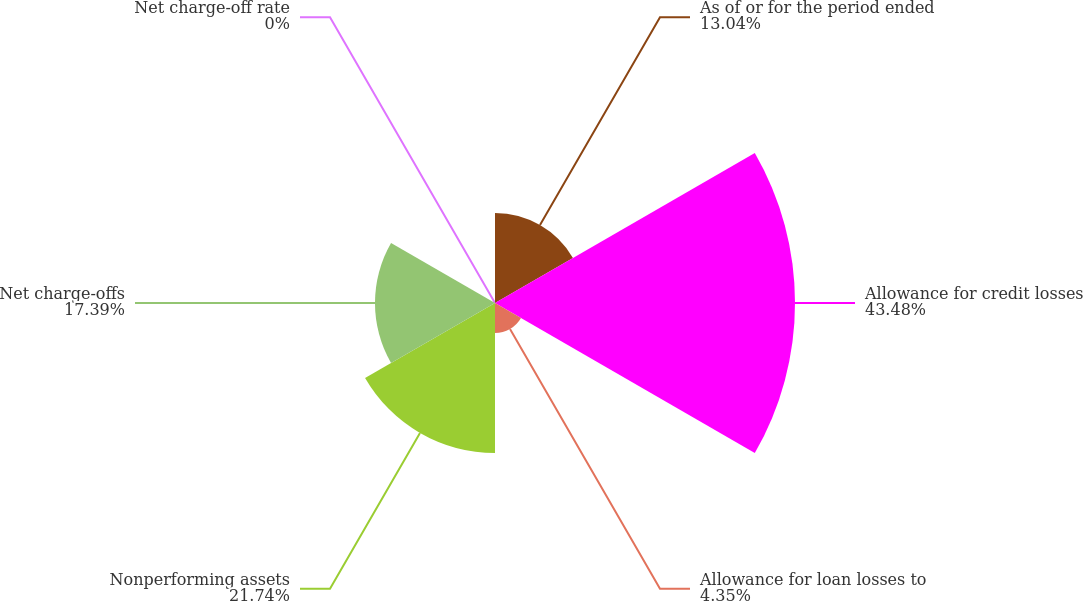<chart> <loc_0><loc_0><loc_500><loc_500><pie_chart><fcel>As of or for the period ended<fcel>Allowance for credit losses<fcel>Allowance for loan losses to<fcel>Nonperforming assets<fcel>Net charge-offs<fcel>Net charge-off rate<nl><fcel>13.04%<fcel>43.47%<fcel>4.35%<fcel>21.74%<fcel>17.39%<fcel>0.0%<nl></chart> 